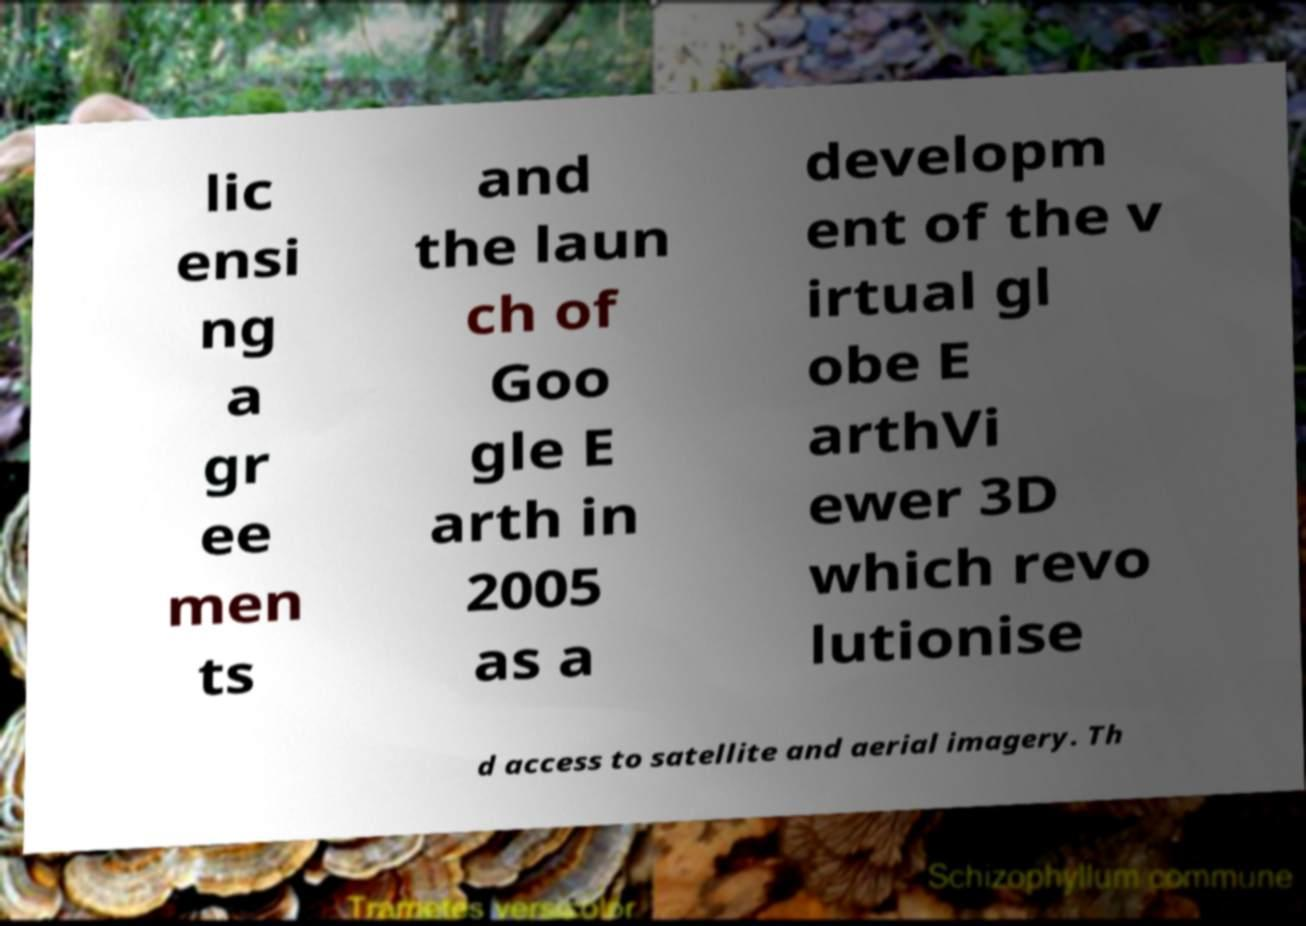Please identify and transcribe the text found in this image. lic ensi ng a gr ee men ts and the laun ch of Goo gle E arth in 2005 as a developm ent of the v irtual gl obe E arthVi ewer 3D which revo lutionise d access to satellite and aerial imagery. Th 